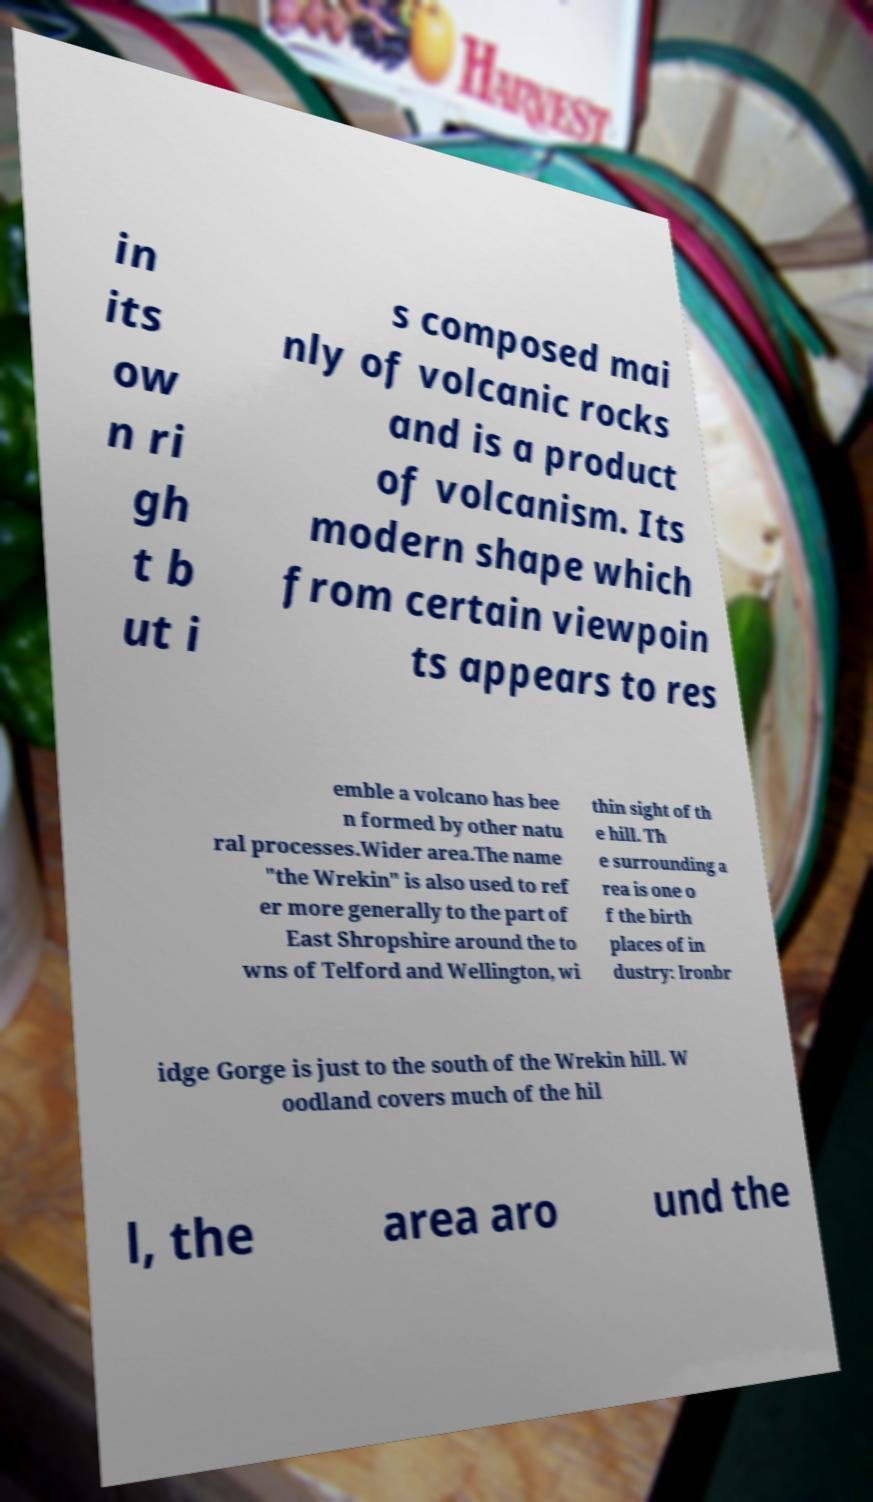Could you assist in decoding the text presented in this image and type it out clearly? in its ow n ri gh t b ut i s composed mai nly of volcanic rocks and is a product of volcanism. Its modern shape which from certain viewpoin ts appears to res emble a volcano has bee n formed by other natu ral processes.Wider area.The name "the Wrekin" is also used to ref er more generally to the part of East Shropshire around the to wns of Telford and Wellington, wi thin sight of th e hill. Th e surrounding a rea is one o f the birth places of in dustry: Ironbr idge Gorge is just to the south of the Wrekin hill. W oodland covers much of the hil l, the area aro und the 